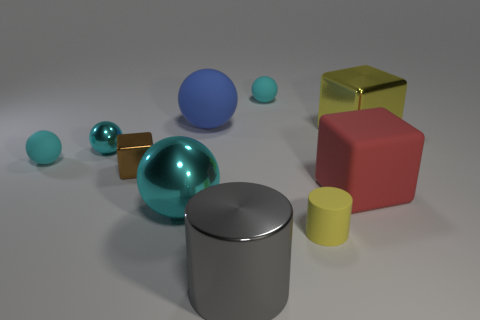How many cyan spheres must be subtracted to get 2 cyan spheres? 2 Subtract all yellow blocks. How many blocks are left? 2 Subtract all gray cubes. How many cyan spheres are left? 4 Subtract all blue balls. How many balls are left? 4 Subtract 3 balls. How many balls are left? 2 Subtract all yellow spheres. Subtract all green blocks. How many spheres are left? 5 Subtract 0 purple cylinders. How many objects are left? 10 Subtract all cylinders. How many objects are left? 8 Subtract all large red cubes. Subtract all blue rubber balls. How many objects are left? 8 Add 8 big shiny cubes. How many big shiny cubes are left? 9 